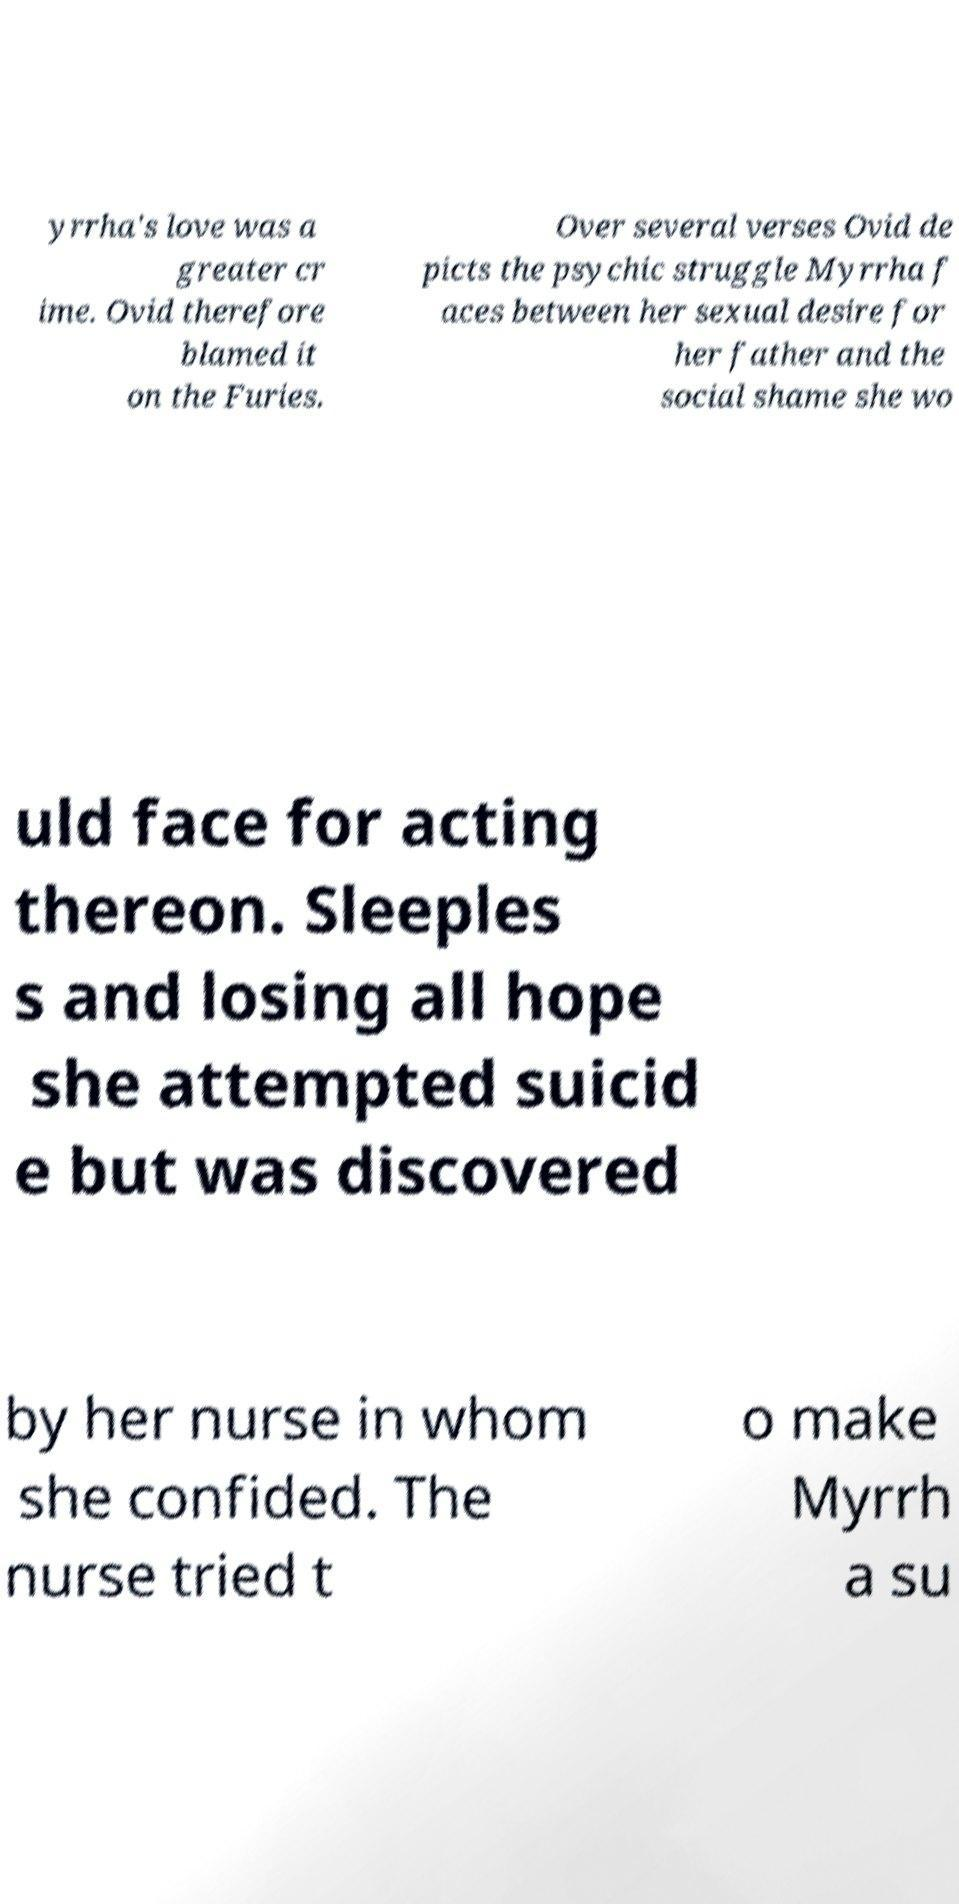For documentation purposes, I need the text within this image transcribed. Could you provide that? yrrha's love was a greater cr ime. Ovid therefore blamed it on the Furies. Over several verses Ovid de picts the psychic struggle Myrrha f aces between her sexual desire for her father and the social shame she wo uld face for acting thereon. Sleeples s and losing all hope she attempted suicid e but was discovered by her nurse in whom she confided. The nurse tried t o make Myrrh a su 